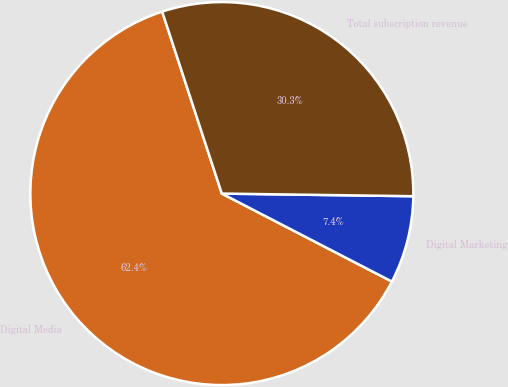Convert chart. <chart><loc_0><loc_0><loc_500><loc_500><pie_chart><fcel>Digital Media<fcel>Digital Marketing<fcel>Total subscription revenue<nl><fcel>62.36%<fcel>7.38%<fcel>30.26%<nl></chart> 